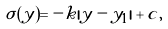<formula> <loc_0><loc_0><loc_500><loc_500>\sigma ( y ) = - k | y - y _ { 1 } | + c , \,</formula> 